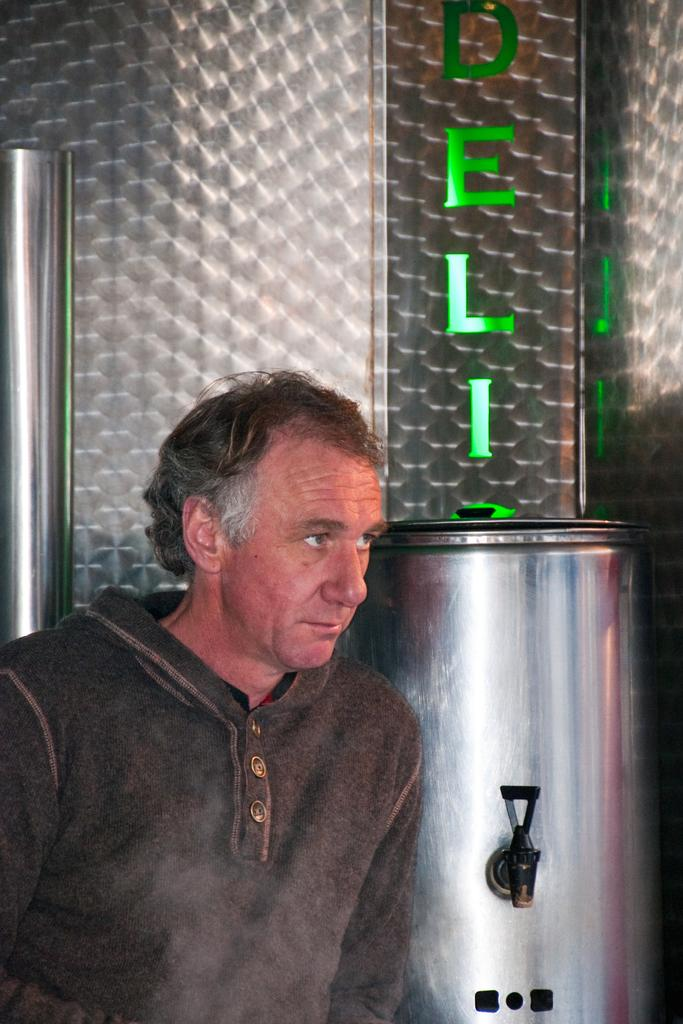<image>
Write a terse but informative summary of the picture. a man standing in front of a silver tank under a green sign that reads deli 